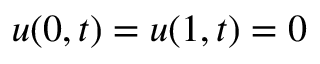Convert formula to latex. <formula><loc_0><loc_0><loc_500><loc_500>u ( 0 , t ) = u ( 1 , t ) = 0</formula> 